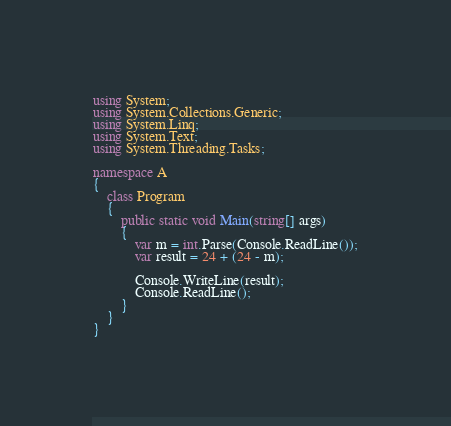Convert code to text. <code><loc_0><loc_0><loc_500><loc_500><_C#_>using System;
using System.Collections.Generic;
using System.Linq;
using System.Text;
using System.Threading.Tasks;

namespace A
{
    class Program
    {
        public static void Main(string[] args)
        {
            var m = int.Parse(Console.ReadLine());
            var result = 24 + (24 - m);

            Console.WriteLine(result);
            Console.ReadLine();
        }
    }
}</code> 